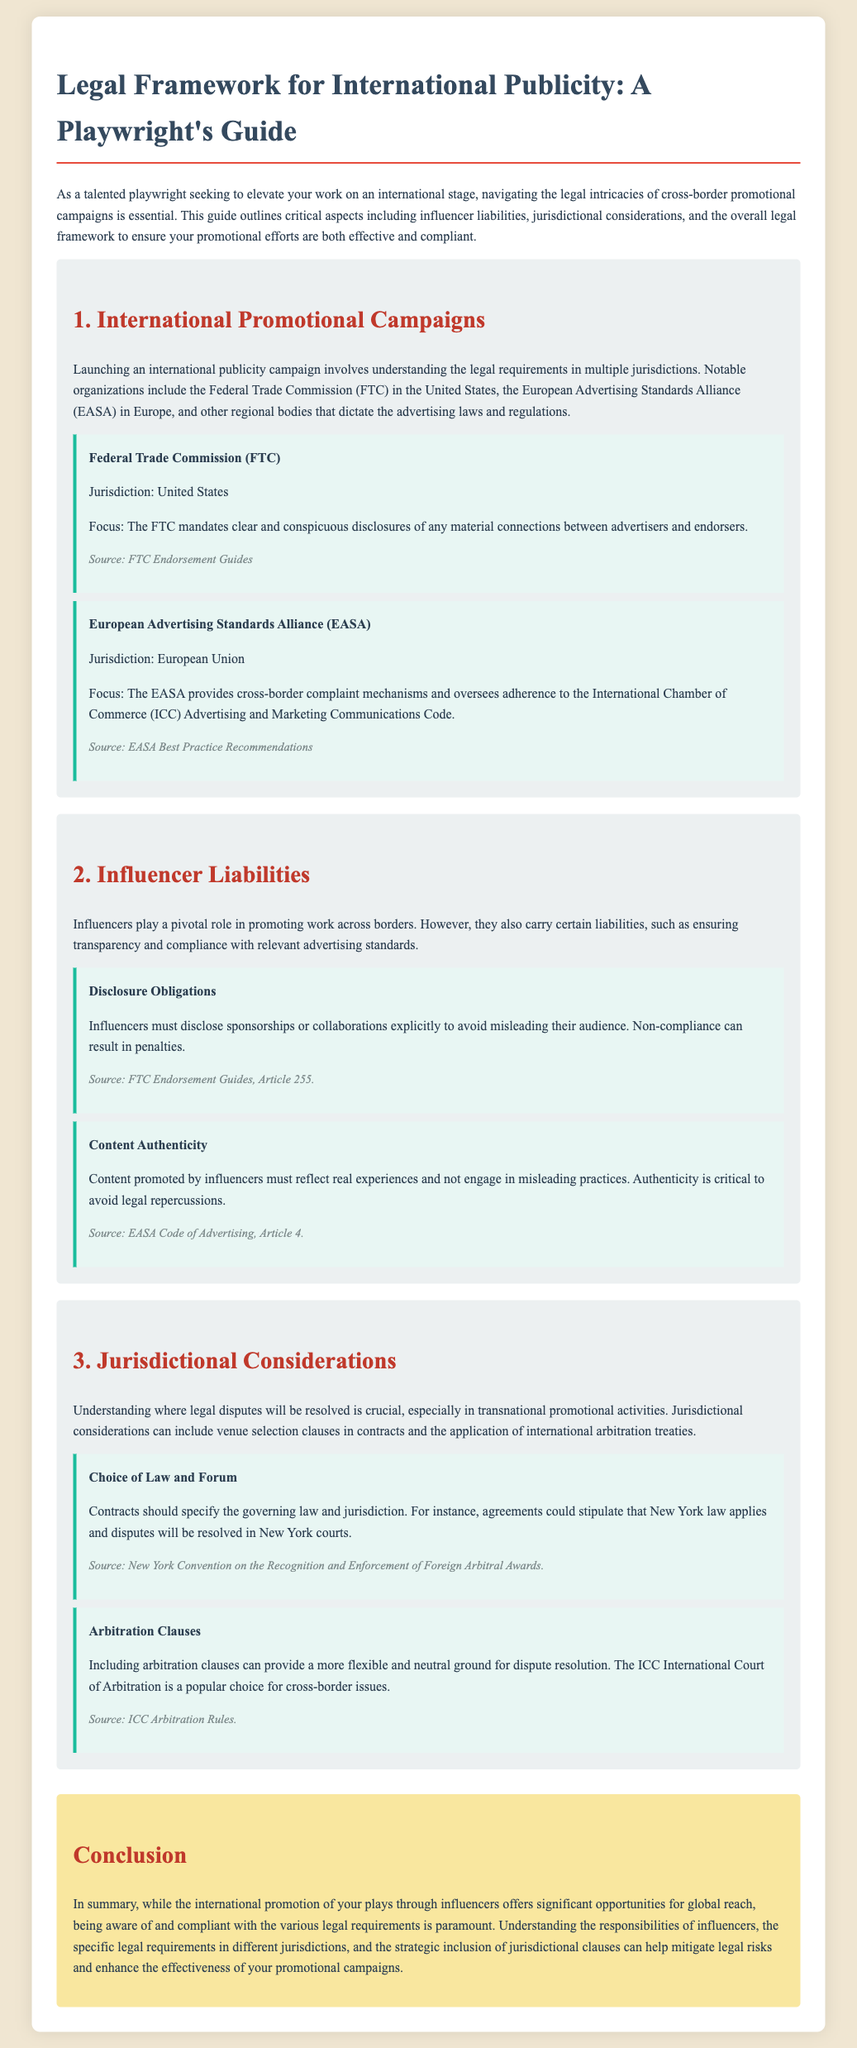What organization oversees advertising laws in the U.S.? The Federal Trade Commission (FTC) is the organization that mandates advertising laws in the U.S.
Answer: Federal Trade Commission (FTC) What is a key focus of the EASA? The EASA oversees adherence to the International Chamber of Commerce (ICC) Advertising and Marketing Communications Code.
Answer: Cross-border complaint mechanisms What must influencers disclose to avoid legal repercussions? Influencers must disclose sponsorships or collaborations explicitly to avoid misleading their audience.
Answer: Sponsorships or collaborations Which article outlines content authenticity requirements? Article 4 of the EASA Code of Advertising addresses content authenticity.
Answer: Article 4 What should contracts specify regarding disputes? Contracts should specify the governing law and jurisdiction for dispute resolution.
Answer: Governing law and jurisdiction Which arbitration court is popular for cross-border issues? The ICC International Court of Arbitration is a popular choice for cross-border issues.
Answer: ICC International Court of Arbitration What is the primary document type being analyzed? The document is a legal brief providing guidance on international publicity.
Answer: Legal brief What color is used for the section backgrounds? The section backgrounds use a light gray color.
Answer: Light gray What guideline is referenced for advertising disclosures in the U.S.? The FTC Endorsement Guides are referenced for advertising disclosures in the U.S.
Answer: FTC Endorsement Guides 